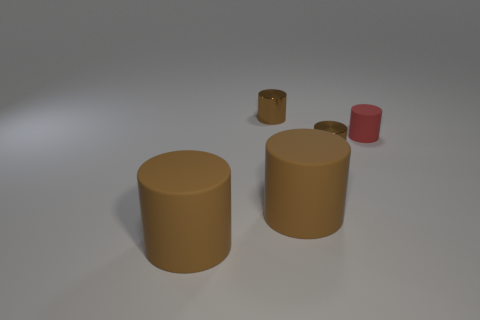Subtract all brown cylinders. How many were subtracted if there are2brown cylinders left? 2 Subtract all green blocks. How many brown cylinders are left? 4 Subtract all red cylinders. How many cylinders are left? 4 Subtract all red matte cylinders. How many cylinders are left? 4 Subtract all cyan cylinders. Subtract all blue cubes. How many cylinders are left? 5 Add 1 large things. How many objects exist? 6 Subtract all large brown cylinders. Subtract all matte cylinders. How many objects are left? 0 Add 3 red matte objects. How many red matte objects are left? 4 Add 1 big brown cylinders. How many big brown cylinders exist? 3 Subtract 0 cyan spheres. How many objects are left? 5 